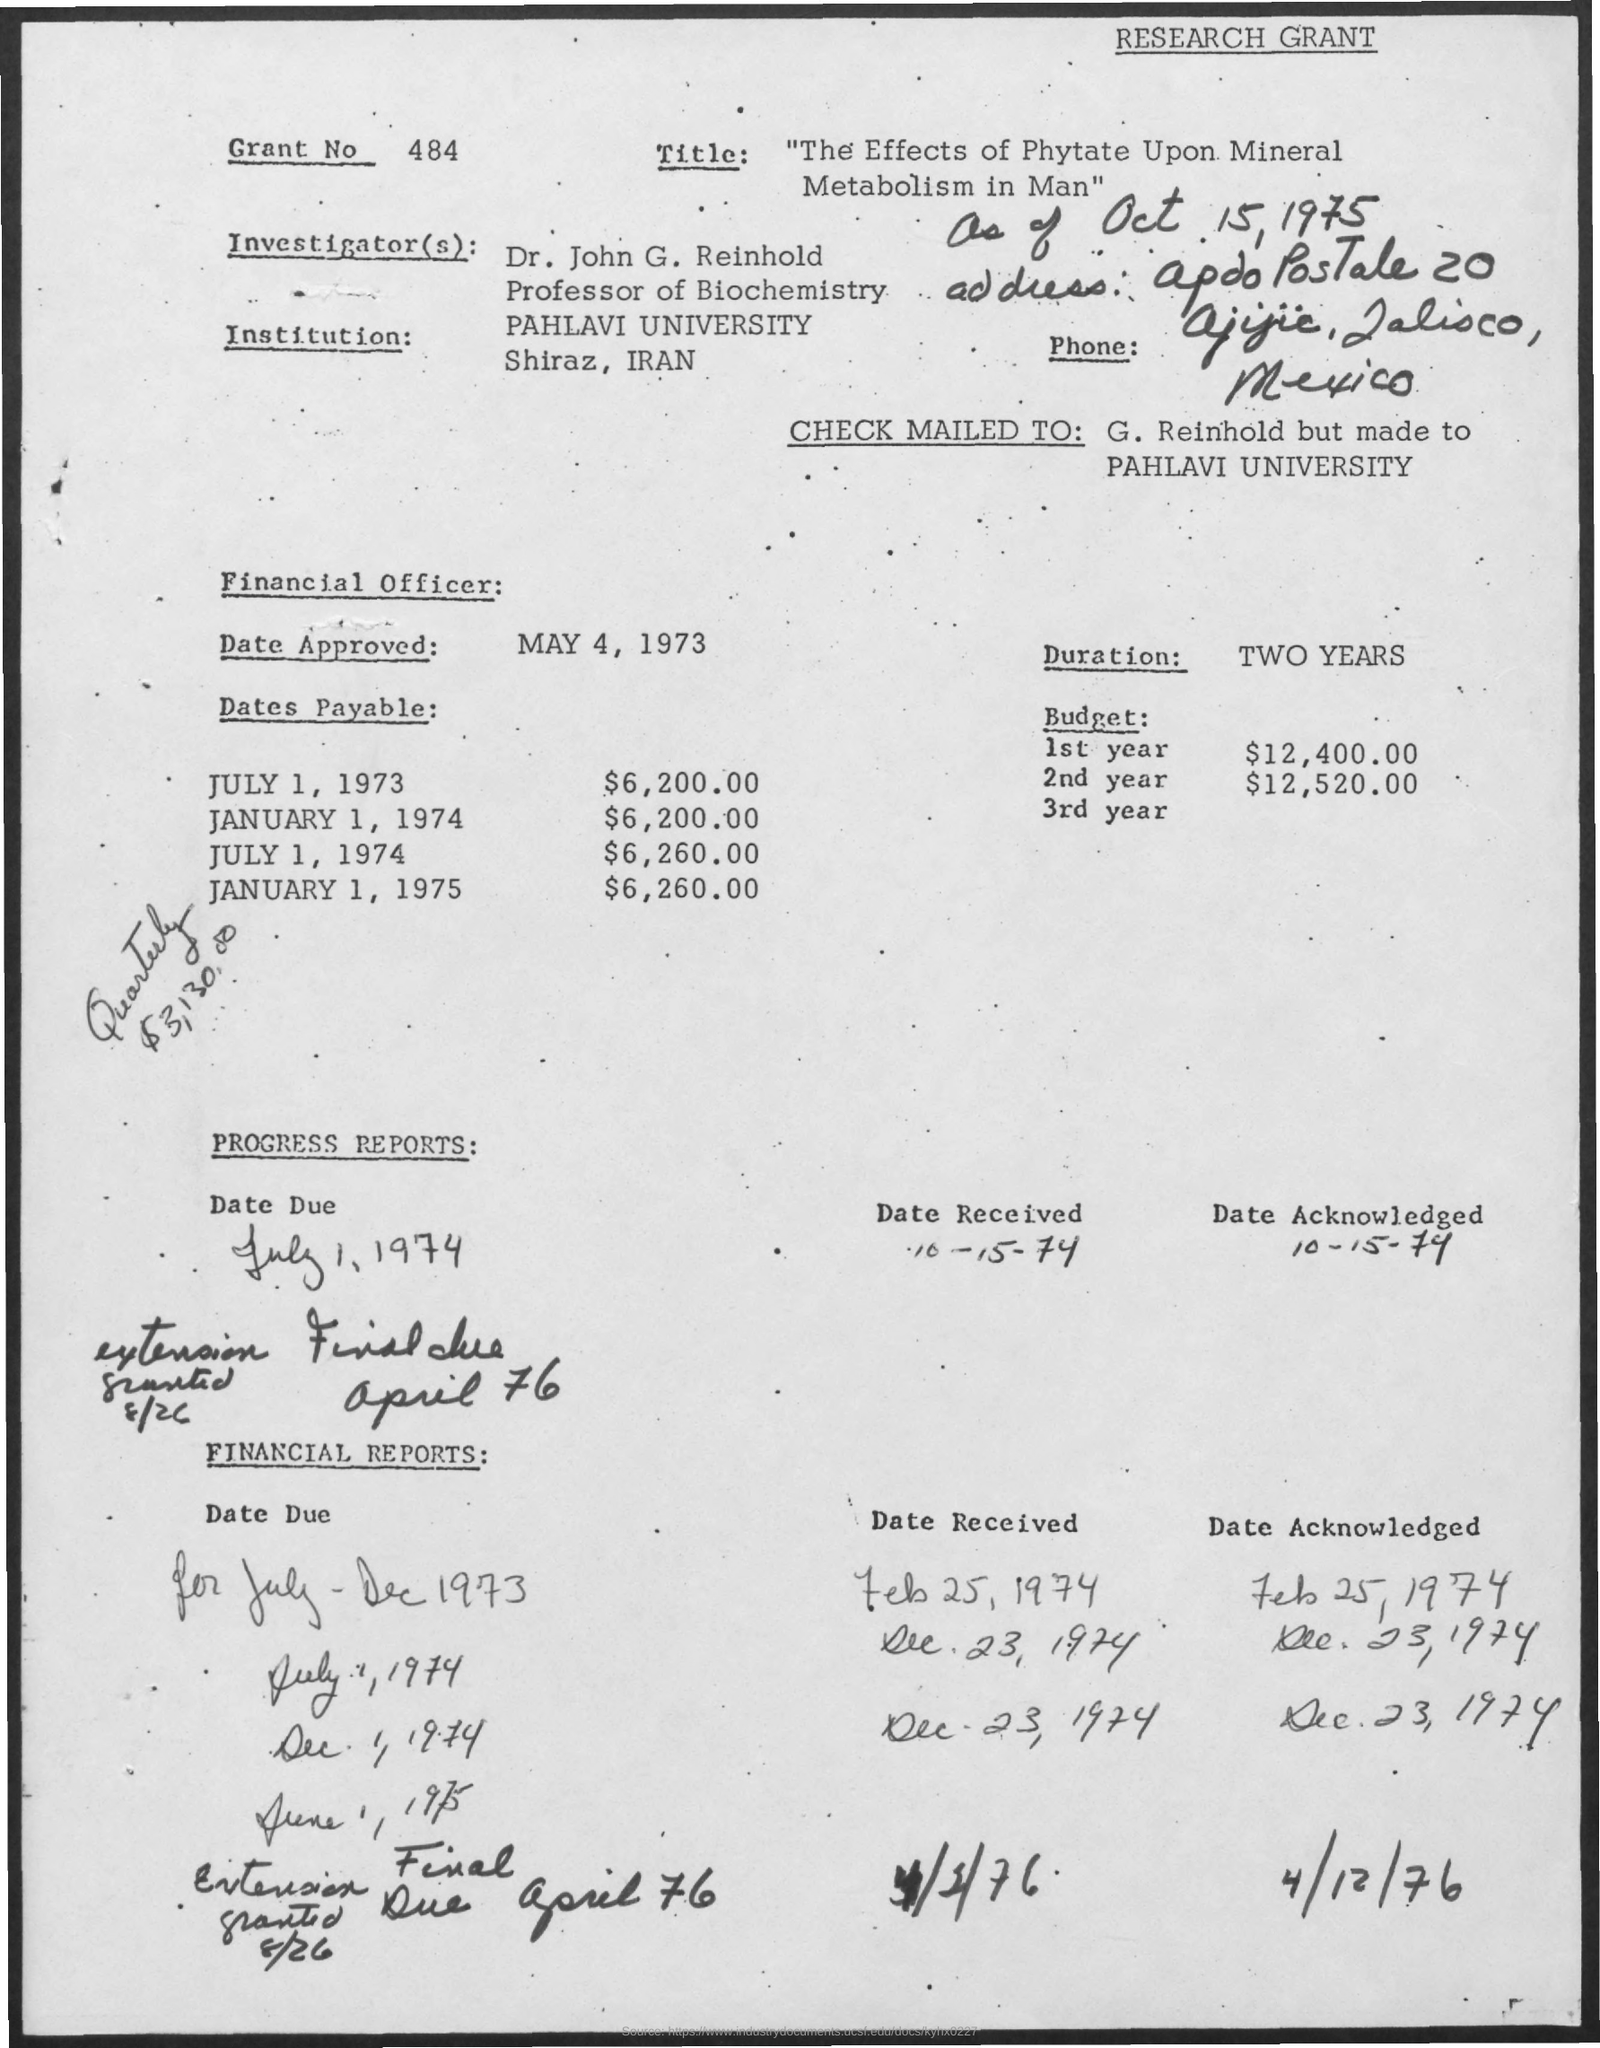Identify some key points in this picture. The date received in the progress report is October 15, 1974. The duration is two years. PAHLAVI UNIVERSITY is located in Shiraz, IRAN. On July 1, 1974, the amount payable was $6,260.00. On May 4, 1973, the Financial Officer approved the CHECK. 